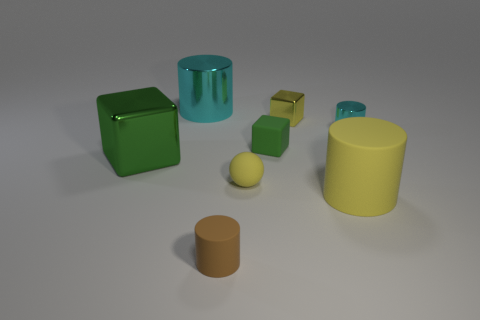Is the color of the metal cube on the left side of the small green block the same as the small metal cube?
Your answer should be compact. No. What number of metallic objects are big green things or big cyan cylinders?
Offer a terse response. 2. Is there any other thing that has the same size as the green metallic block?
Make the answer very short. Yes. What is the color of the big thing that is the same material as the yellow ball?
Offer a very short reply. Yellow. What number of cylinders are yellow objects or tiny cyan shiny things?
Your answer should be compact. 2. What number of things are either big cylinders or cyan cylinders that are in front of the tiny yellow shiny object?
Your answer should be compact. 3. Is there a yellow shiny sphere?
Provide a short and direct response. No. What number of small spheres have the same color as the small matte cube?
Give a very brief answer. 0. There is a large object that is the same color as the ball; what is its material?
Keep it short and to the point. Rubber. What size is the yellow matte thing that is on the right side of the green cube to the right of the green metal object?
Give a very brief answer. Large. 